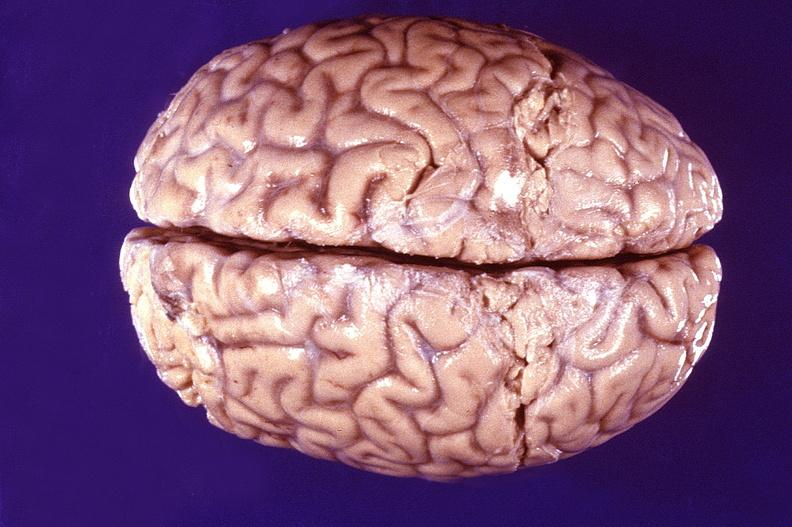what is present?
Answer the question using a single word or phrase. Nervous 